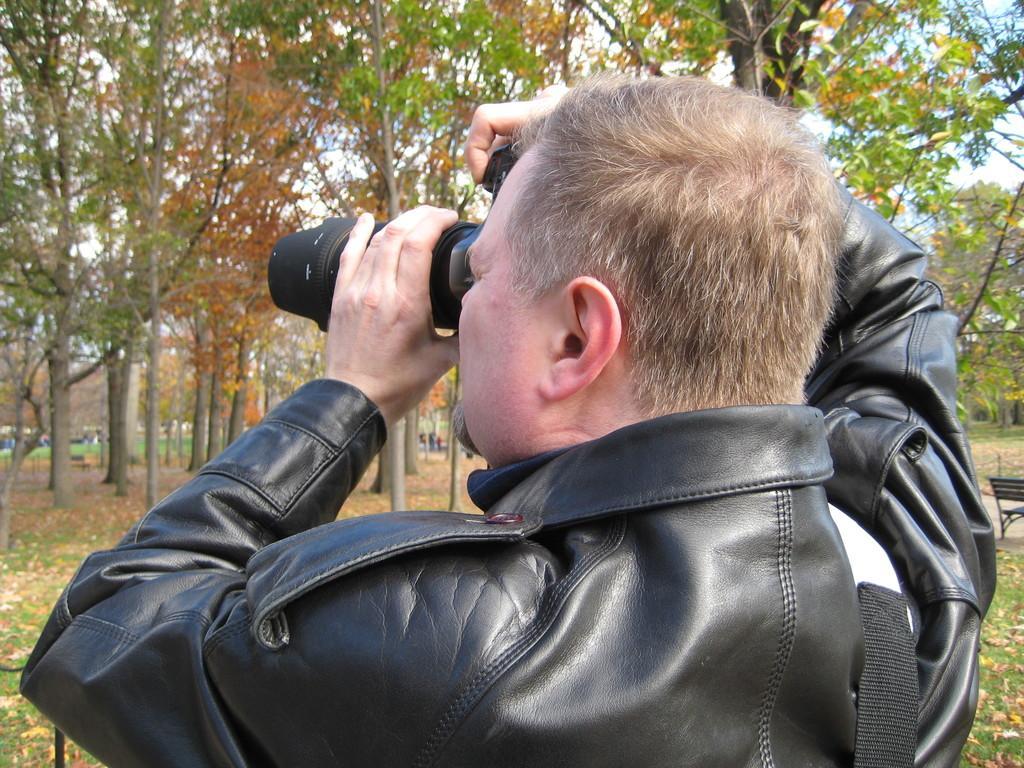Can you describe this image briefly? In this picture we can see man wore jacket holding camera with his hand and taking pictures and in background we can see tree, grass, some persons, bench. 